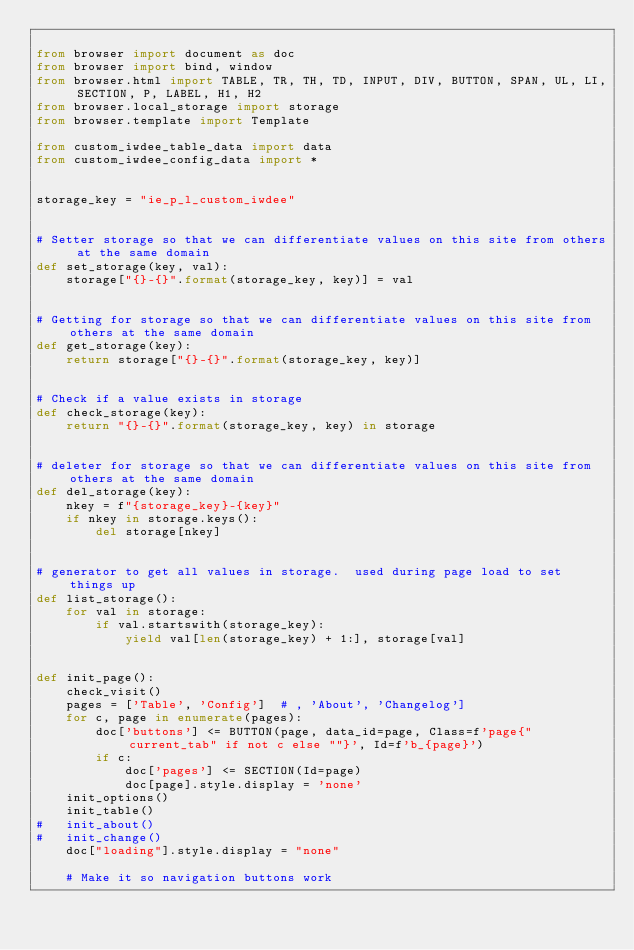Convert code to text. <code><loc_0><loc_0><loc_500><loc_500><_Python_>
from browser import document as doc
from browser import bind, window
from browser.html import TABLE, TR, TH, TD, INPUT, DIV, BUTTON, SPAN, UL, LI, SECTION, P, LABEL, H1, H2
from browser.local_storage import storage
from browser.template import Template

from custom_iwdee_table_data import data
from custom_iwdee_config_data import *


storage_key = "ie_p_l_custom_iwdee"


# Setter storage so that we can differentiate values on this site from others at the same domain
def set_storage(key, val):
	storage["{}-{}".format(storage_key, key)] = val


# Getting for storage so that we can differentiate values on this site from others at the same domain
def get_storage(key):
	return storage["{}-{}".format(storage_key, key)]


# Check if a value exists in storage
def check_storage(key):
	return "{}-{}".format(storage_key, key) in storage


# deleter for storage so that we can differentiate values on this site from others at the same domain
def del_storage(key):
	nkey = f"{storage_key}-{key}"
	if nkey in storage.keys():
		del storage[nkey]


# generator to get all values in storage.  used during page load to set things up
def list_storage():
	for val in storage:
		if val.startswith(storage_key):
			yield val[len(storage_key) + 1:], storage[val]


def init_page():
	check_visit()
	pages = ['Table', 'Config']  # , 'About', 'Changelog']
	for c, page in enumerate(pages):
		doc['buttons'] <= BUTTON(page, data_id=page, Class=f'page{" current_tab" if not c else ""}', Id=f'b_{page}')
		if c:
			doc['pages'] <= SECTION(Id=page)
			doc[page].style.display = 'none'
	init_options()
	init_table()
#	init_about()
#	init_change()
	doc["loading"].style.display = "none"

	# Make it so navigation buttons work</code> 